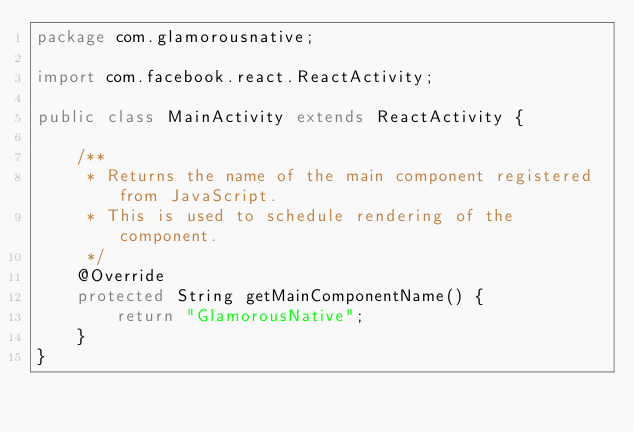Convert code to text. <code><loc_0><loc_0><loc_500><loc_500><_Java_>package com.glamorousnative;

import com.facebook.react.ReactActivity;

public class MainActivity extends ReactActivity {

    /**
     * Returns the name of the main component registered from JavaScript.
     * This is used to schedule rendering of the component.
     */
    @Override
    protected String getMainComponentName() {
        return "GlamorousNative";
    }
}
</code> 